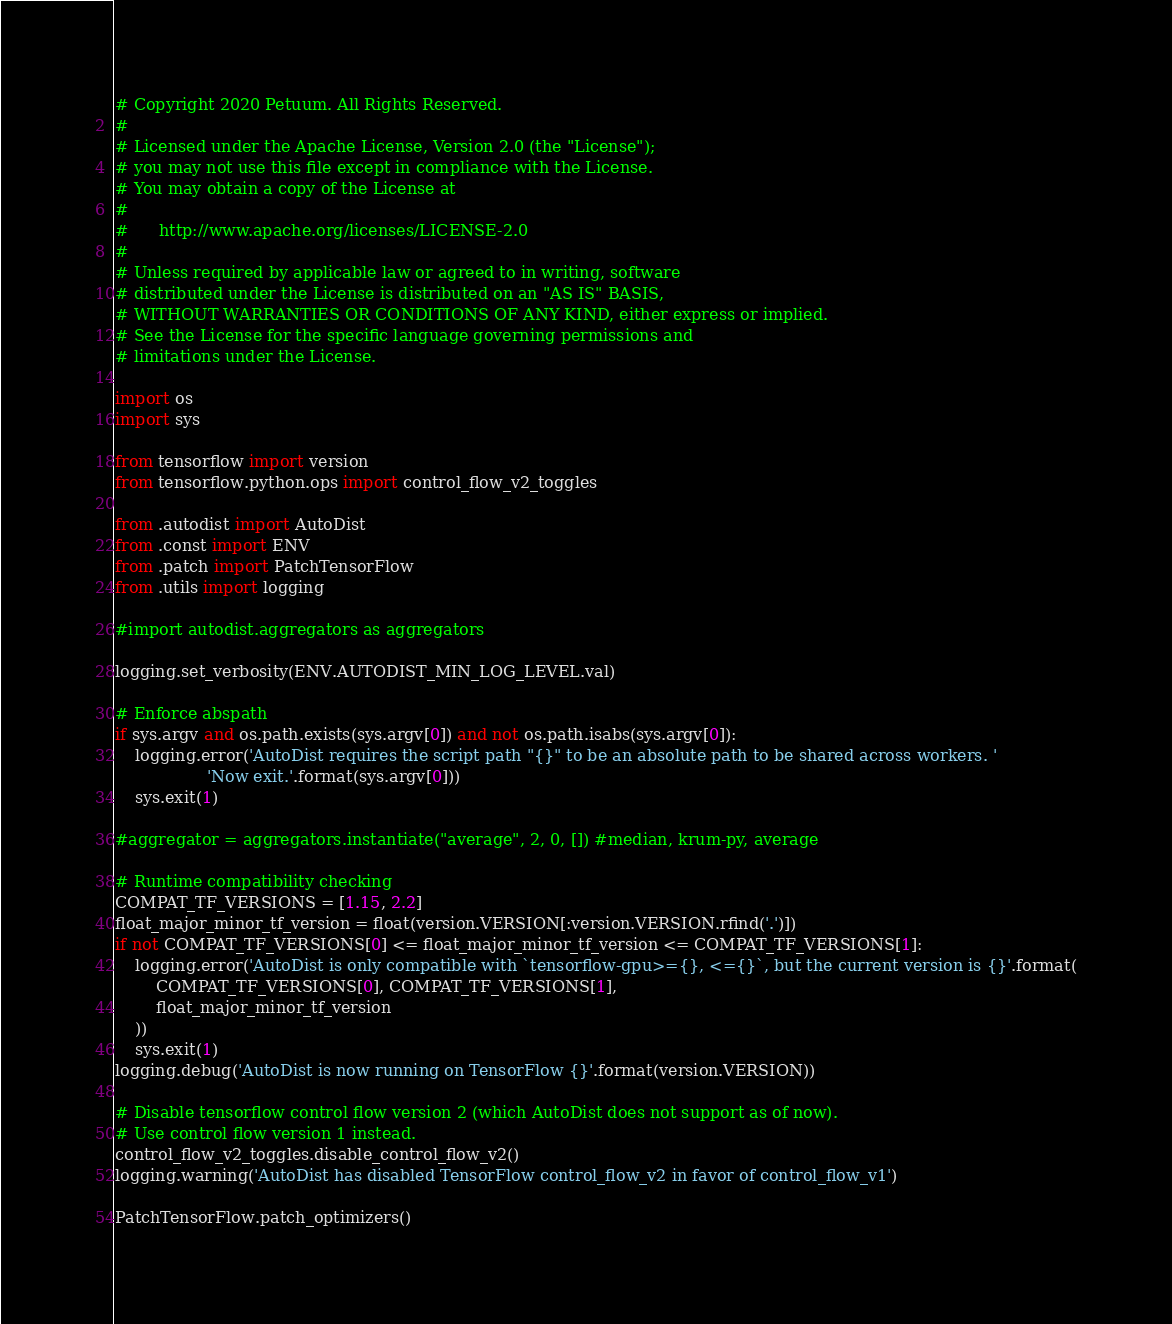Convert code to text. <code><loc_0><loc_0><loc_500><loc_500><_Python_># Copyright 2020 Petuum. All Rights Reserved.
#
# Licensed under the Apache License, Version 2.0 (the "License");
# you may not use this file except in compliance with the License.
# You may obtain a copy of the License at
#
#      http://www.apache.org/licenses/LICENSE-2.0
#
# Unless required by applicable law or agreed to in writing, software
# distributed under the License is distributed on an "AS IS" BASIS,
# WITHOUT WARRANTIES OR CONDITIONS OF ANY KIND, either express or implied.
# See the License for the specific language governing permissions and
# limitations under the License.

import os
import sys

from tensorflow import version
from tensorflow.python.ops import control_flow_v2_toggles

from .autodist import AutoDist
from .const import ENV
from .patch import PatchTensorFlow
from .utils import logging

#import autodist.aggregators as aggregators

logging.set_verbosity(ENV.AUTODIST_MIN_LOG_LEVEL.val)

# Enforce abspath
if sys.argv and os.path.exists(sys.argv[0]) and not os.path.isabs(sys.argv[0]):
    logging.error('AutoDist requires the script path "{}" to be an absolute path to be shared across workers. '
                  'Now exit.'.format(sys.argv[0]))
    sys.exit(1)

#aggregator = aggregators.instantiate("average", 2, 0, []) #median, krum-py, average

# Runtime compatibility checking
COMPAT_TF_VERSIONS = [1.15, 2.2]
float_major_minor_tf_version = float(version.VERSION[:version.VERSION.rfind('.')])
if not COMPAT_TF_VERSIONS[0] <= float_major_minor_tf_version <= COMPAT_TF_VERSIONS[1]:
    logging.error('AutoDist is only compatible with `tensorflow-gpu>={}, <={}`, but the current version is {}'.format(
        COMPAT_TF_VERSIONS[0], COMPAT_TF_VERSIONS[1],
        float_major_minor_tf_version
    ))
    sys.exit(1)
logging.debug('AutoDist is now running on TensorFlow {}'.format(version.VERSION))

# Disable tensorflow control flow version 2 (which AutoDist does not support as of now).
# Use control flow version 1 instead.
control_flow_v2_toggles.disable_control_flow_v2()
logging.warning('AutoDist has disabled TensorFlow control_flow_v2 in favor of control_flow_v1')

PatchTensorFlow.patch_optimizers()
</code> 